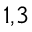<formula> <loc_0><loc_0><loc_500><loc_500>^ { 1 , 3 }</formula> 